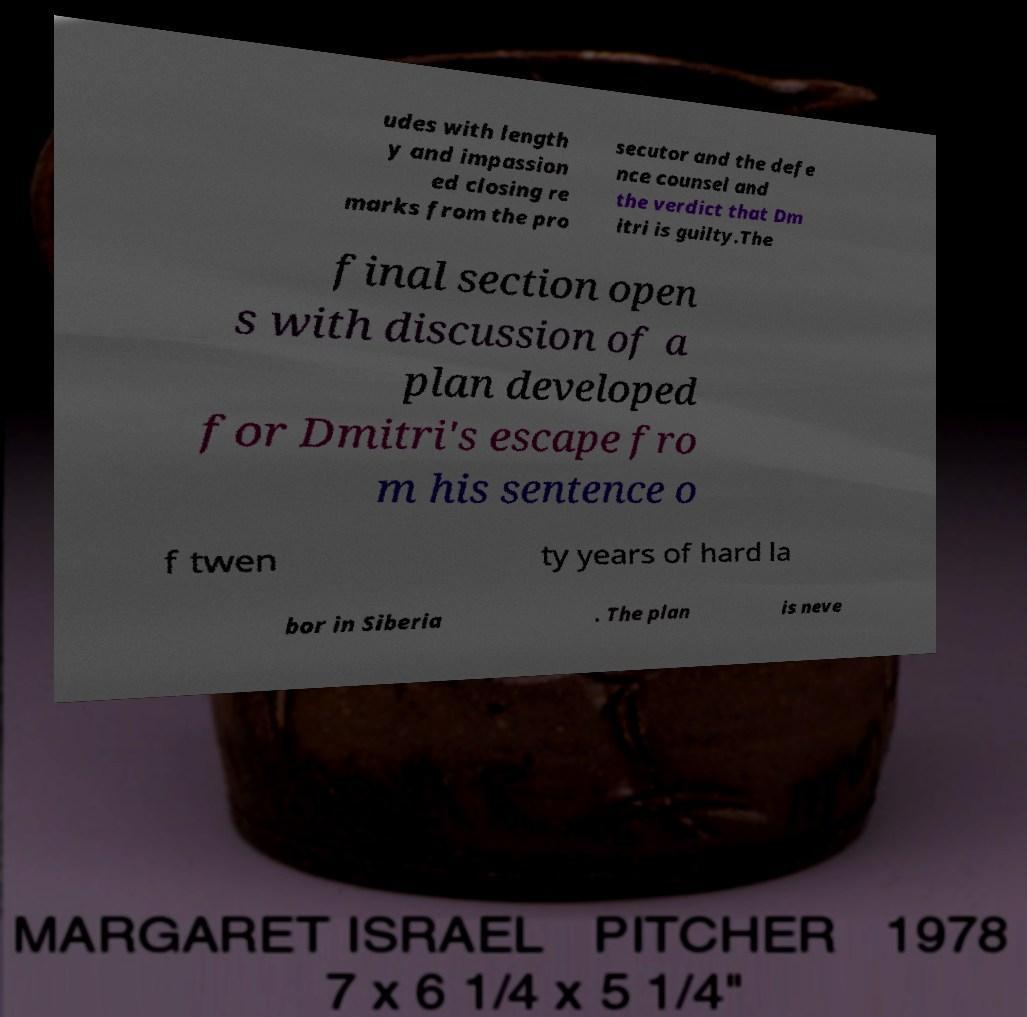Could you extract and type out the text from this image? udes with length y and impassion ed closing re marks from the pro secutor and the defe nce counsel and the verdict that Dm itri is guilty.The final section open s with discussion of a plan developed for Dmitri's escape fro m his sentence o f twen ty years of hard la bor in Siberia . The plan is neve 